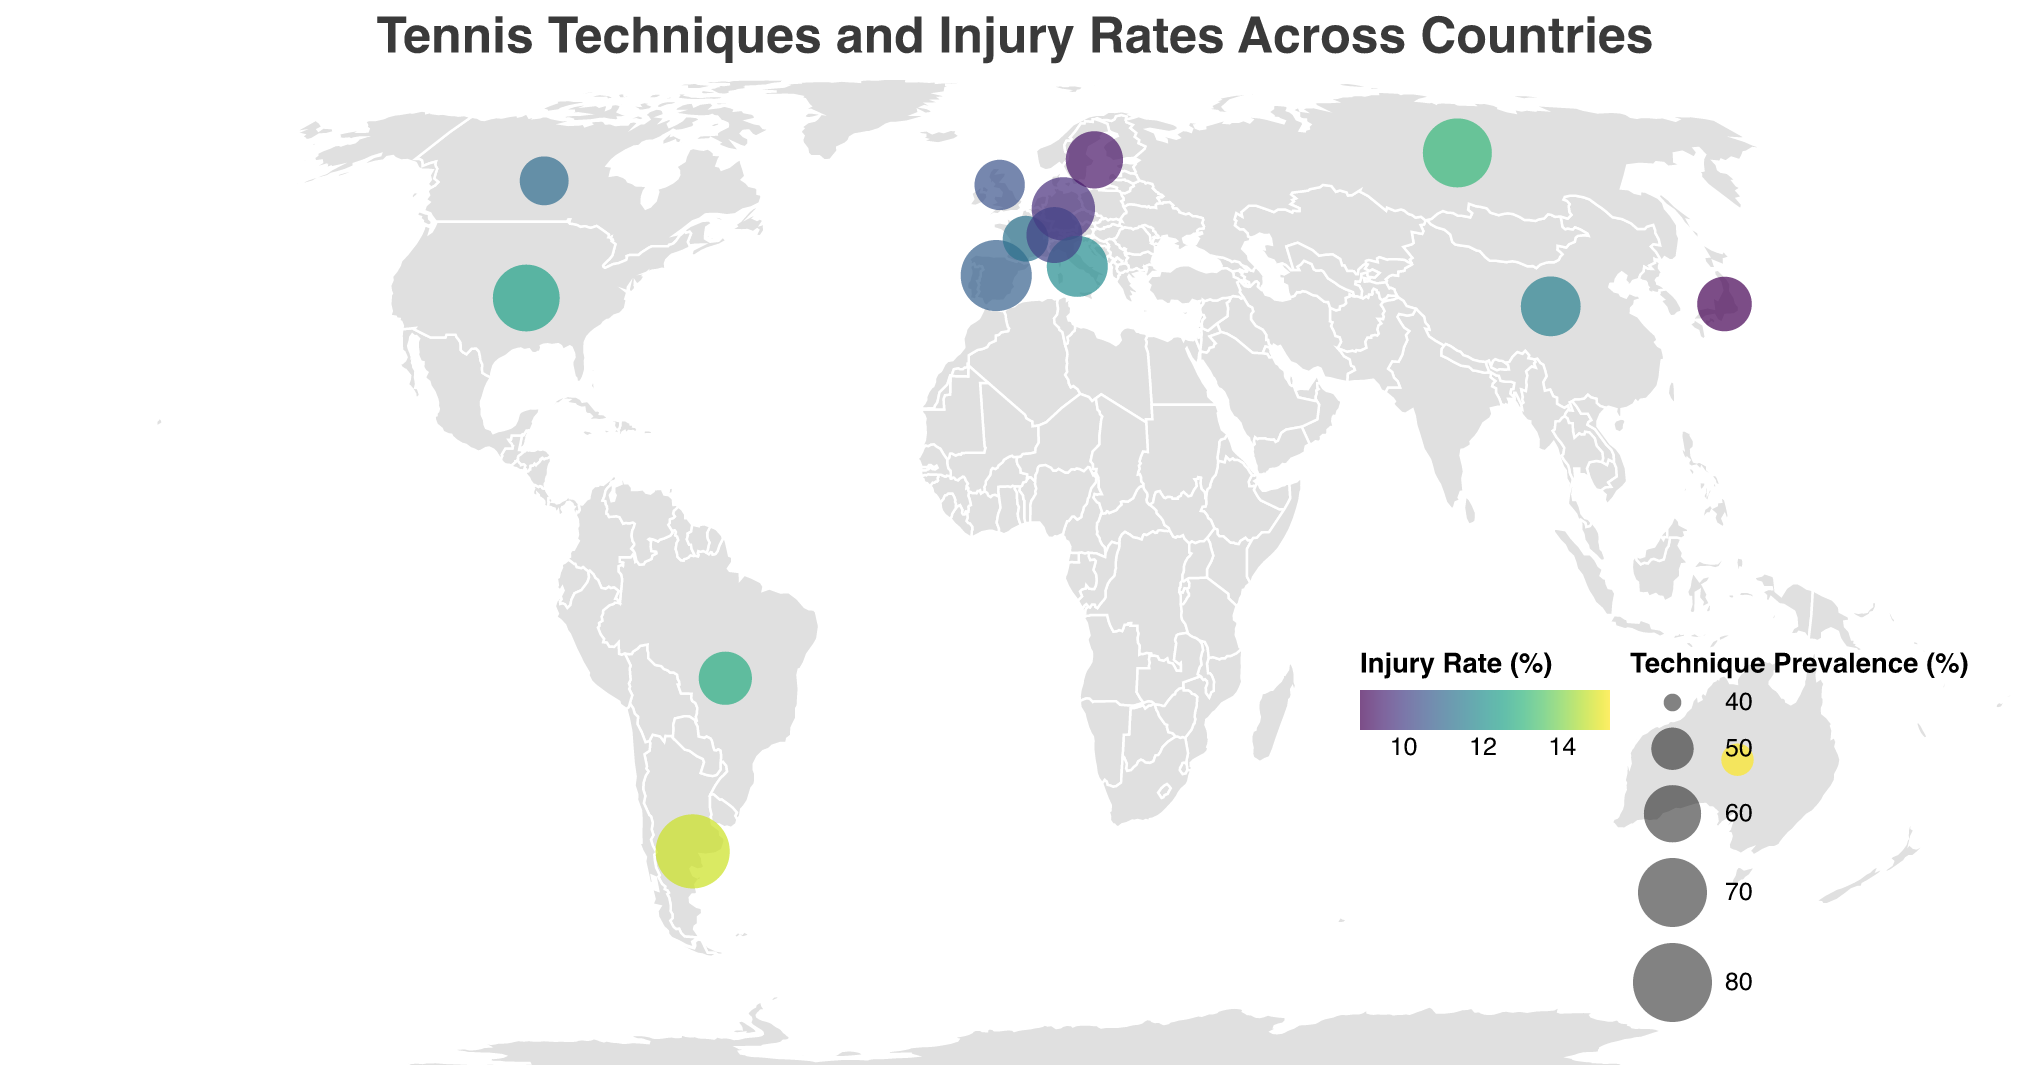Which country has the highest injury rate? The highest injury rate can be seen by looking for the most intense color in the color legend that represents "Injury Rate (%)". Australia's circle is the darkest, indicating the highest injury rate.
Answer: Australia What is the dominant technique in the United Kingdom? By locating the United Kingdom on the map (using the latitude and longitude), we can check the tooltip or label associated with it to see the dominant tennis technique.
Answer: Slice Backhand Which country has the least technique prevalence? The least technique prevalence can be identified by looking for the smallest circle on the map, which appears to be Australia.
Answer: Australia Compare the injury rates between Spain and Germany. Which country has a lower injury rate and by how much? Spain and Germany need to be located on the map. Spain has an injury rate of 10.8%, and Germany has 9.7%. Subtracting Germany's rate from Spain's rate gives us the difference.
Answer: Germany by 1.1% What is the average injury rate of the displayed countries? Sum up all the injury rates of the countries and divide by the number of countries to find the average. The injury rates are: 12.5, 10.8, 15.2, 11.3, 9.7, 13.1, 8.9, 10.5, 11.9, 14.7, 9.2, 10.1, 11.6, 12.8, and 11.1. The sum is 182.4, and there are 15 countries, so the average is 182.4 / 15.
Answer: 12.16% Which country's dominant technique is Western Forehand Grip, and what is its technique prevalence and injury rate? Locate the country labeled with the dominant technique "Western Forehand Grip" on the map, which is Spain. The tooltip shows the technique prevalence of 72% and an injury rate of 10.8%.
Answer: Spain, 72%, 10.8% Which technique has the highest prevalence, and in which country is it dominant? The highest technique prevalence is represented by the largest circle on the map, which is Argentina with a prevalence of 75%. The dominant technique there is "Clay Court Sliding".
Answer: Clay Court Sliding, Argentina 